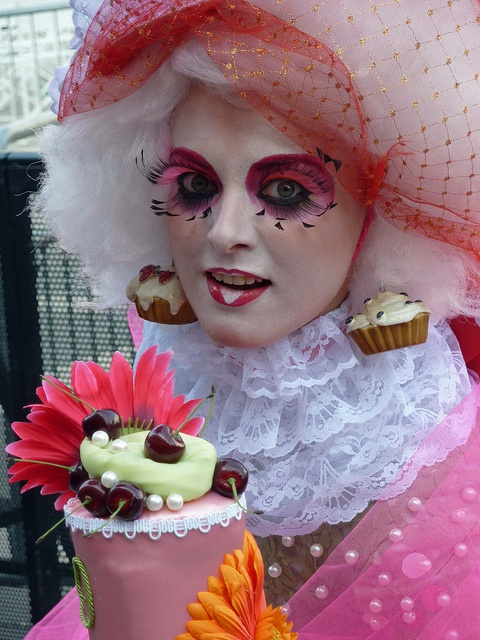Describe the objects in this image and their specific colors. I can see people in lightgray, darkgray, brown, gray, and maroon tones, cake in lightgray, brown, and black tones, cake in lightgray, maroon, and darkgray tones, and cake in lightgray, maroon, gray, and black tones in this image. 